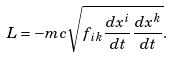<formula> <loc_0><loc_0><loc_500><loc_500>L = - m c \sqrt { f _ { i k } \frac { d x ^ { i } } { d t } \frac { d x ^ { k } } { d t } } .</formula> 